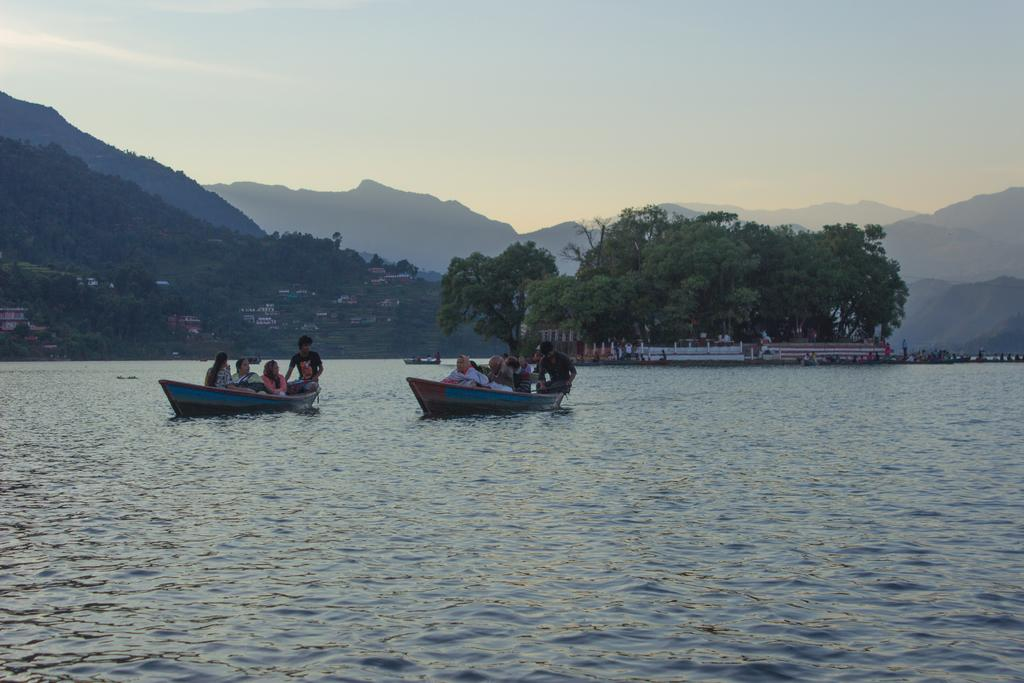What are the people in the image doing? The people are sitting on boats in the image. Where are the boats located? The boats are on the water in the image. What else can be seen in the image besides the boats and people? There are buildings, trees, hills, and the sky visible in the image. What type of metal is used to make the whistle in the image? There is no whistle present in the image. How does the group of people look at each other in the image? The image does not show the people looking at each other; it only shows them sitting on boats. 